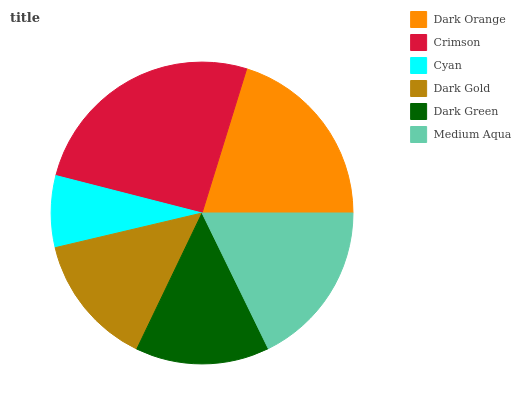Is Cyan the minimum?
Answer yes or no. Yes. Is Crimson the maximum?
Answer yes or no. Yes. Is Crimson the minimum?
Answer yes or no. No. Is Cyan the maximum?
Answer yes or no. No. Is Crimson greater than Cyan?
Answer yes or no. Yes. Is Cyan less than Crimson?
Answer yes or no. Yes. Is Cyan greater than Crimson?
Answer yes or no. No. Is Crimson less than Cyan?
Answer yes or no. No. Is Medium Aqua the high median?
Answer yes or no. Yes. Is Dark Green the low median?
Answer yes or no. Yes. Is Crimson the high median?
Answer yes or no. No. Is Dark Orange the low median?
Answer yes or no. No. 